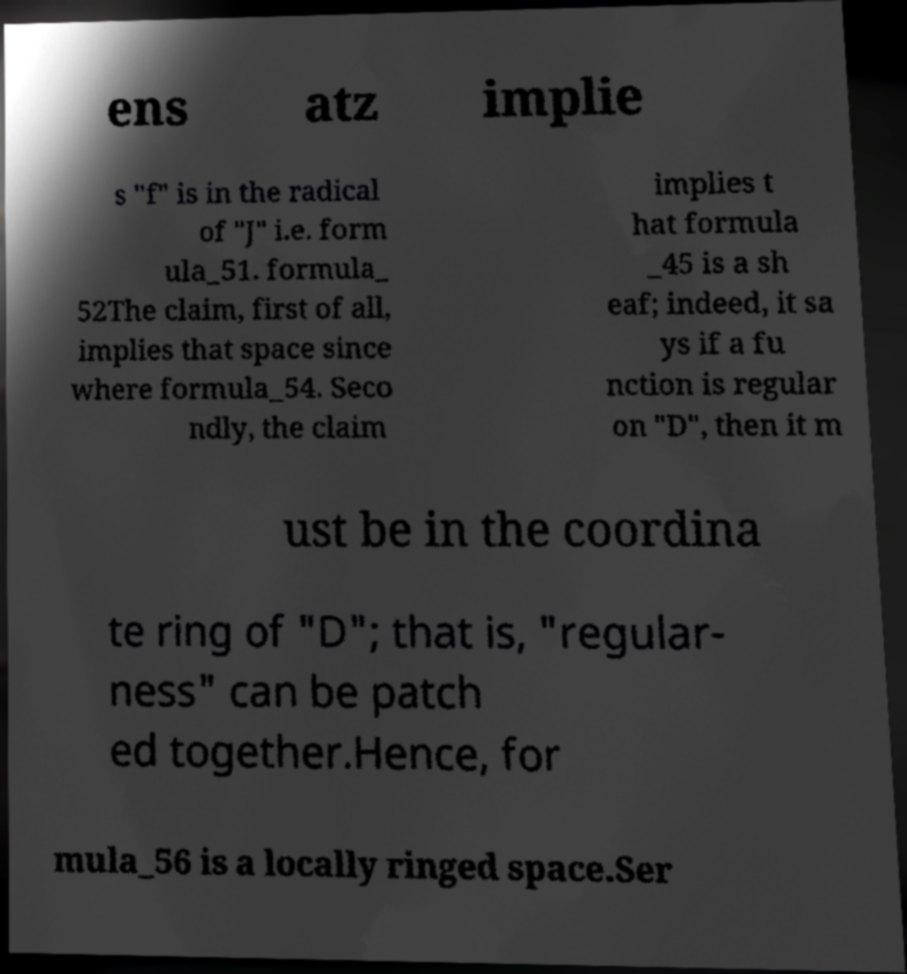Can you accurately transcribe the text from the provided image for me? ens atz implie s "f" is in the radical of "J" i.e. form ula_51. formula_ 52The claim, first of all, implies that space since where formula_54. Seco ndly, the claim implies t hat formula _45 is a sh eaf; indeed, it sa ys if a fu nction is regular on "D", then it m ust be in the coordina te ring of "D"; that is, "regular- ness" can be patch ed together.Hence, for mula_56 is a locally ringed space.Ser 